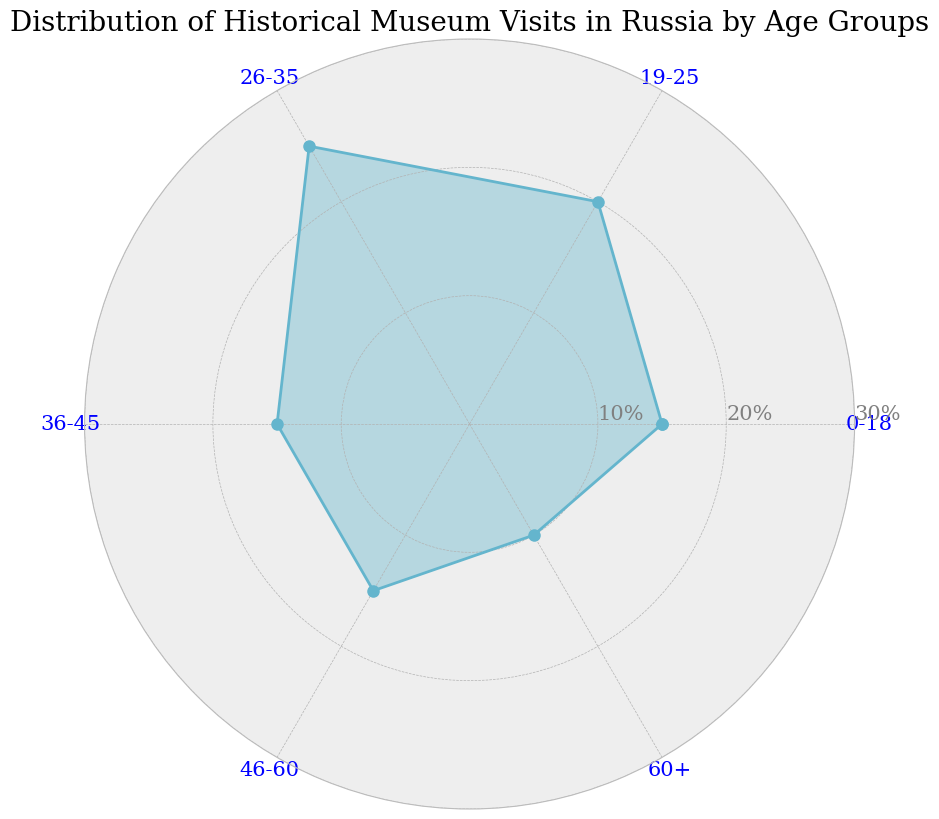Which age group has the highest percentage of historical museum visits? By examining the figure, the segment corresponding to the 26-35 age group is the farthest from the center and at 25%, which is the highest.
Answer: 26-35 What is the total percentage of historical museum visits for the age groups 0-18 and 19-25 combined? To find the total, add the percentage values for the 0-18 group (15%) and the 19-25 group (20%): 15% + 20% = 35%.
Answer: 35% Compare the museum visit percentages between the age groups 36-45 and 46-60. Which group has a higher percentage, and by how much? Both age groups 36-45 and 46-60 have a visit percentage of 15%. There is no difference in their values.
Answer: Equal, 0% What is the average percentage of historical museum visits among all age groups? Sum up all percentages: 15% + 20% + 25% + 15% + 15% + 10% = 100%. Divide by the number of groups (6): 100% / 6 ≈ 16.67%.
Answer: Approx. 16.67% Which age group has the lowest percentage of historical museum visits, and what is the percentage? The segment corresponding to the 60+ age group is closest to the center at 10%, the lowest percentage.
Answer: 60+, 10% By how much does the percentage of visits for the age group 26-35 exceed that of the 60+ age group? Subtract the percentage for the 60+ group (10%) from that of the 26-35 group (25%): 25% - 10% = 15%.
Answer: 15% What is the difference between the highest and lowest percentage of historical museum visits among the age groups? The highest percentage is 25% and the lowest is 10%. Subtract the lowest from the highest: 25% - 10% = 15%.
Answer: 15% Which age group shows an equal percentage of historical museum visits to the 36-45 group, and what is the percentage value? Both the 36-45 and 46-60 groups have a percentage of 15%.
Answer: 46-60, 15% How do the percentages of historical museum visits compare visually between the age groups 0-18 and 60+? The angle corresponding to the 0-18 group is farther out from the center than the angle for the 60+ group, showing a higher percentage visually.
Answer: 0-18 has a higher percentage than 60+ 